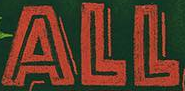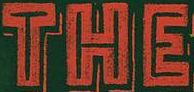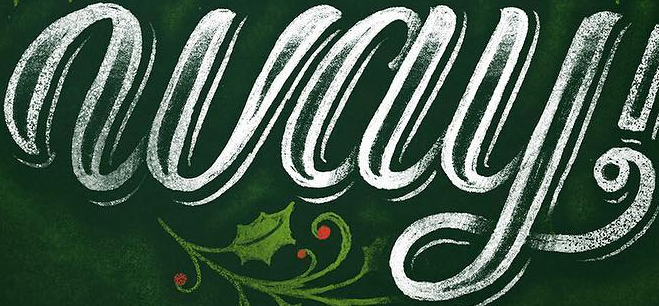What words are shown in these images in order, separated by a semicolon? ALL; THE; way 